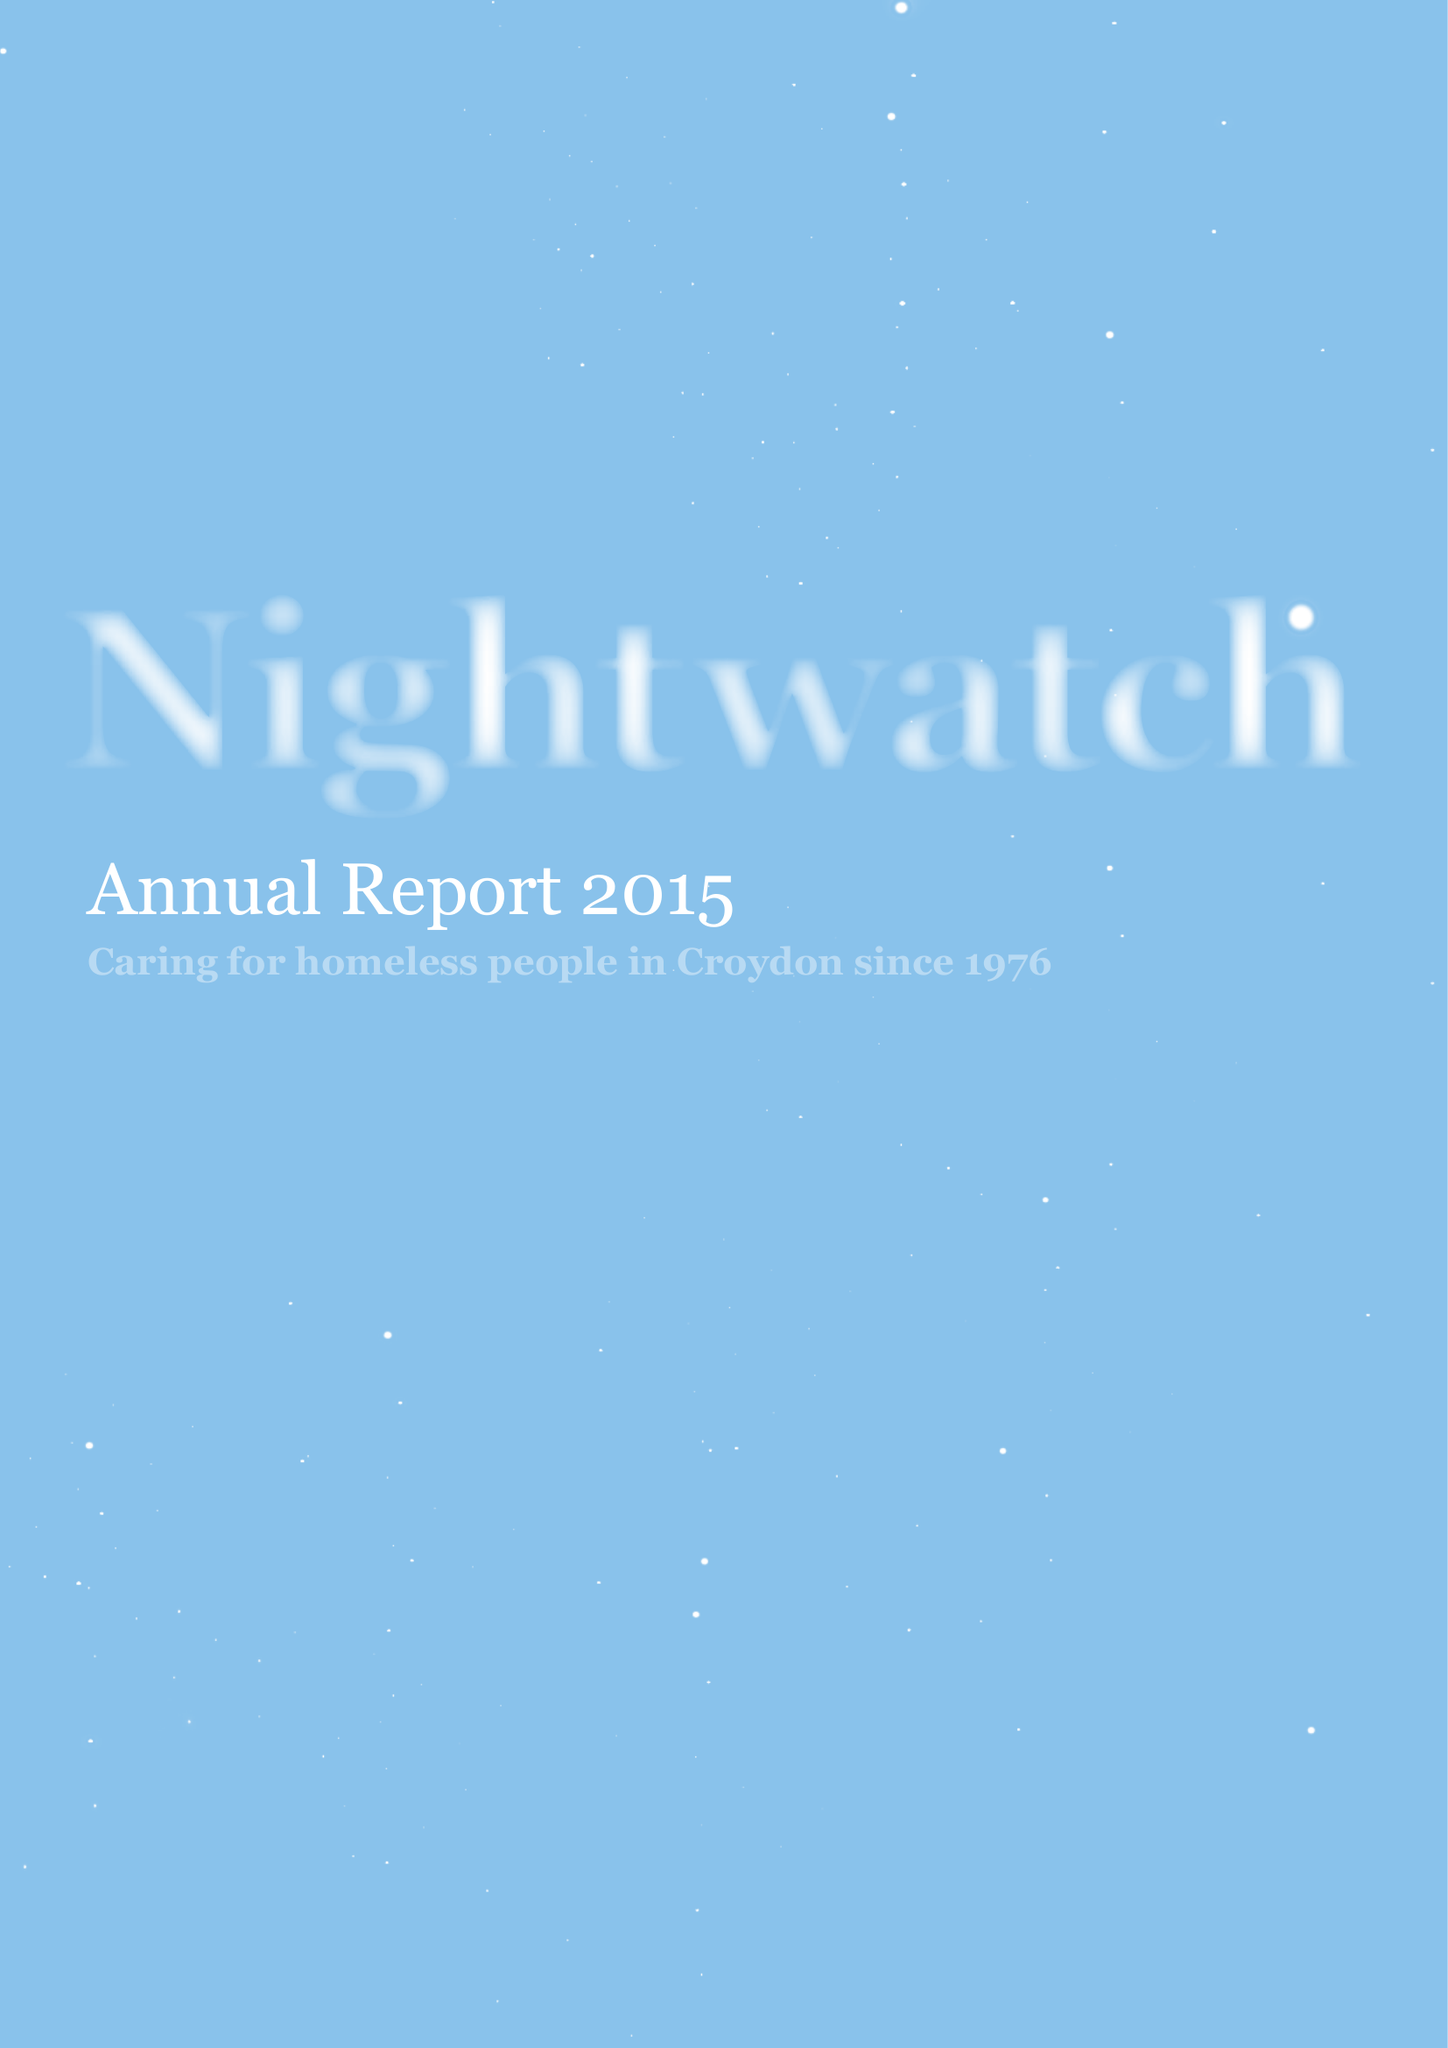What is the value for the address__post_town?
Answer the question using a single word or phrase. LONDON 